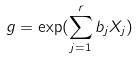<formula> <loc_0><loc_0><loc_500><loc_500>g = \exp ( \sum _ { j = 1 } ^ { r } b _ { j } X _ { j } )</formula> 